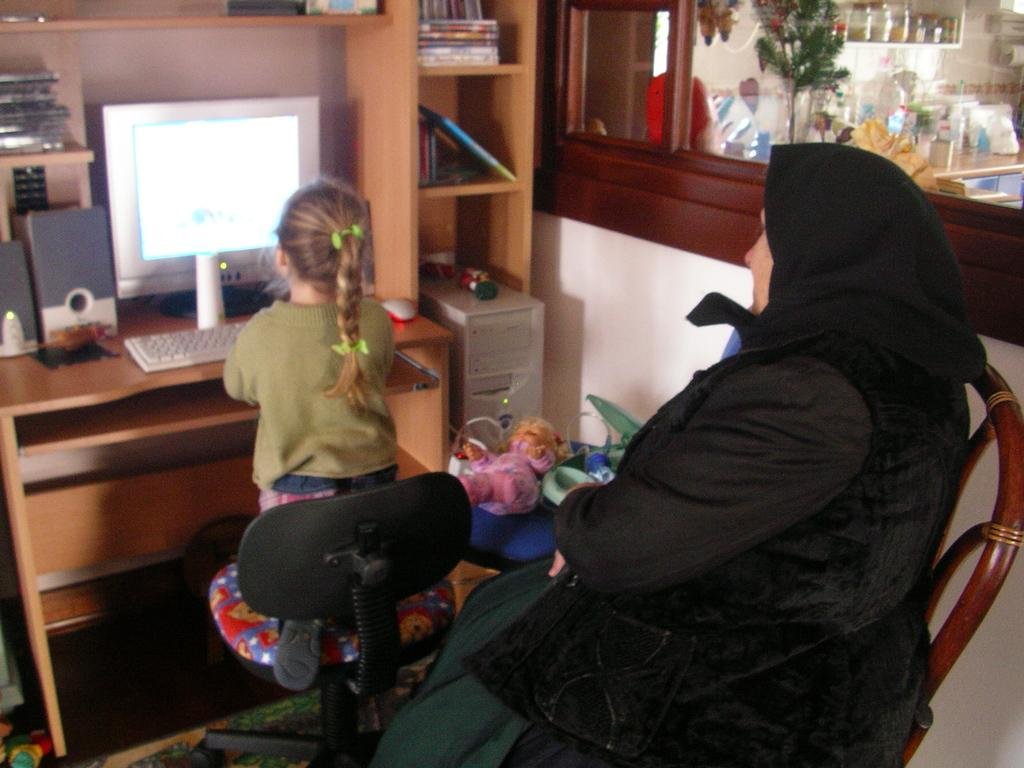How many people are present in the image? There are two people sitting in the image. What is one person doing in the image? One person is operating a computer. Where is the computer located in the image? The computer is placed on a table. What can be found on the table besides the computer? The table has multiple shelves that contain books. What type of butter is being used to lubricate the computer in the image? There is no butter present in the image, nor is there any indication that the computer is being lubricated. 